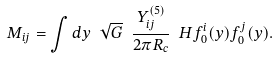<formula> <loc_0><loc_0><loc_500><loc_500>M _ { i j } = \int d y \ \sqrt { G } \ \frac { Y _ { i j } ^ { ( 5 ) } } { 2 \pi R _ { c } } \ H f _ { 0 } ^ { i } ( y ) f _ { 0 } ^ { j } ( y ) .</formula> 